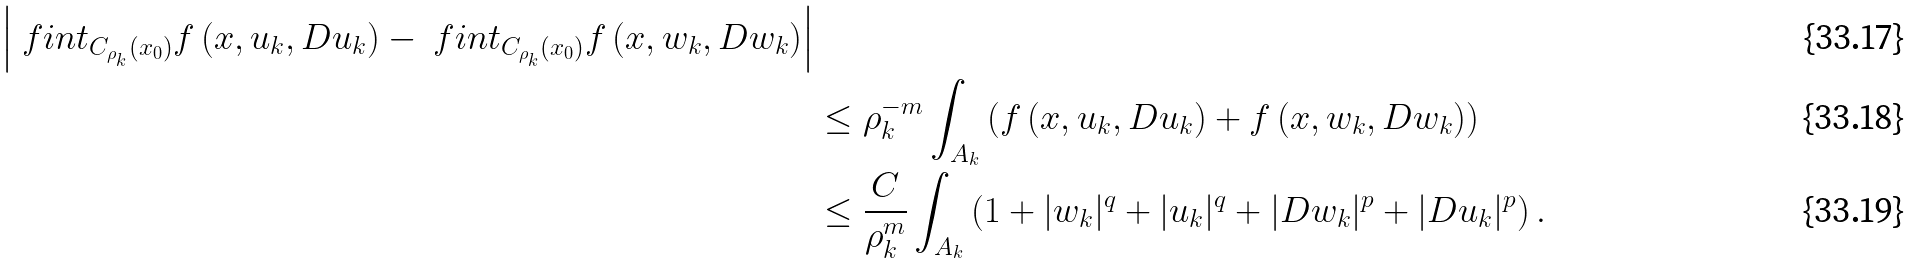<formula> <loc_0><loc_0><loc_500><loc_500>{ \left | \ f i n t _ { C _ { \rho _ { k } } ( x _ { 0 } ) } f \left ( x , u _ { k } , D u _ { k } \right ) - \ f i n t _ { C _ { \rho _ { k } } ( x _ { 0 } ) } f \left ( x , w _ { k } , D w _ { k } \right ) \right | } \\ & \leq \rho _ { k } ^ { - m } \int _ { A _ { k } } \left ( f \left ( x , u _ { k } , D u _ { k } \right ) + f \left ( x , w _ { k } , D w _ { k } \right ) \right ) \\ & \leq \frac { C } { \rho _ { k } ^ { m } } \int _ { A _ { k } } \left ( 1 + | w _ { k } | ^ { q } + | u _ { k } | ^ { q } + | D w _ { k } | ^ { p } + | D u _ { k } | ^ { p } \right ) .</formula> 